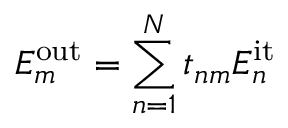<formula> <loc_0><loc_0><loc_500><loc_500>E _ { m } ^ { o u t } = \sum _ { n = 1 } ^ { N } t _ { n m } E _ { n } ^ { i t }</formula> 